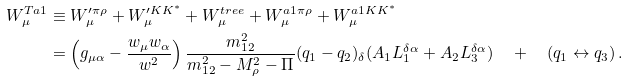Convert formula to latex. <formula><loc_0><loc_0><loc_500><loc_500>W _ { \mu } ^ { T a 1 } & \equiv W _ { \mu } ^ { \prime \pi \rho } + W _ { \mu } ^ { \prime K K ^ { \ast } } + W _ { \mu } ^ { t r e e } + W _ { \mu } ^ { a 1 \pi \rho } + W _ { \mu } ^ { a 1 K K ^ { \ast } } \\ & = \left ( g _ { \mu \alpha } - \frac { w _ { \mu } w _ { \alpha } } { w ^ { 2 } } \right ) \frac { m _ { 1 2 } ^ { 2 } } { m _ { 1 2 } ^ { 2 } - M _ { \rho } ^ { 2 } - \Pi } ( q _ { 1 } - q _ { 2 } ) _ { \delta } ( A _ { 1 } L _ { 1 } ^ { \delta \alpha } + A _ { 2 } L _ { 3 } ^ { \delta \alpha } ) \quad + \quad ( q _ { 1 } \leftrightarrow q _ { 3 } ) \, .</formula> 